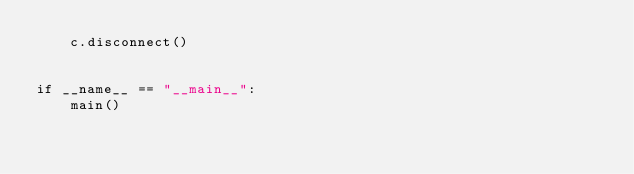Convert code to text. <code><loc_0><loc_0><loc_500><loc_500><_Python_>    c.disconnect()


if __name__ == "__main__":
    main()
</code> 